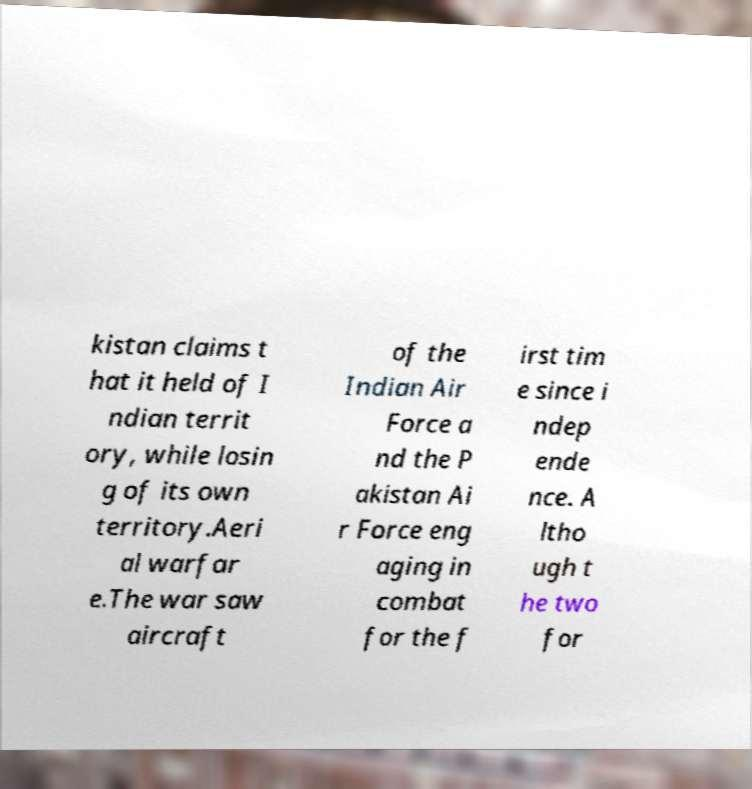I need the written content from this picture converted into text. Can you do that? kistan claims t hat it held of I ndian territ ory, while losin g of its own territory.Aeri al warfar e.The war saw aircraft of the Indian Air Force a nd the P akistan Ai r Force eng aging in combat for the f irst tim e since i ndep ende nce. A ltho ugh t he two for 